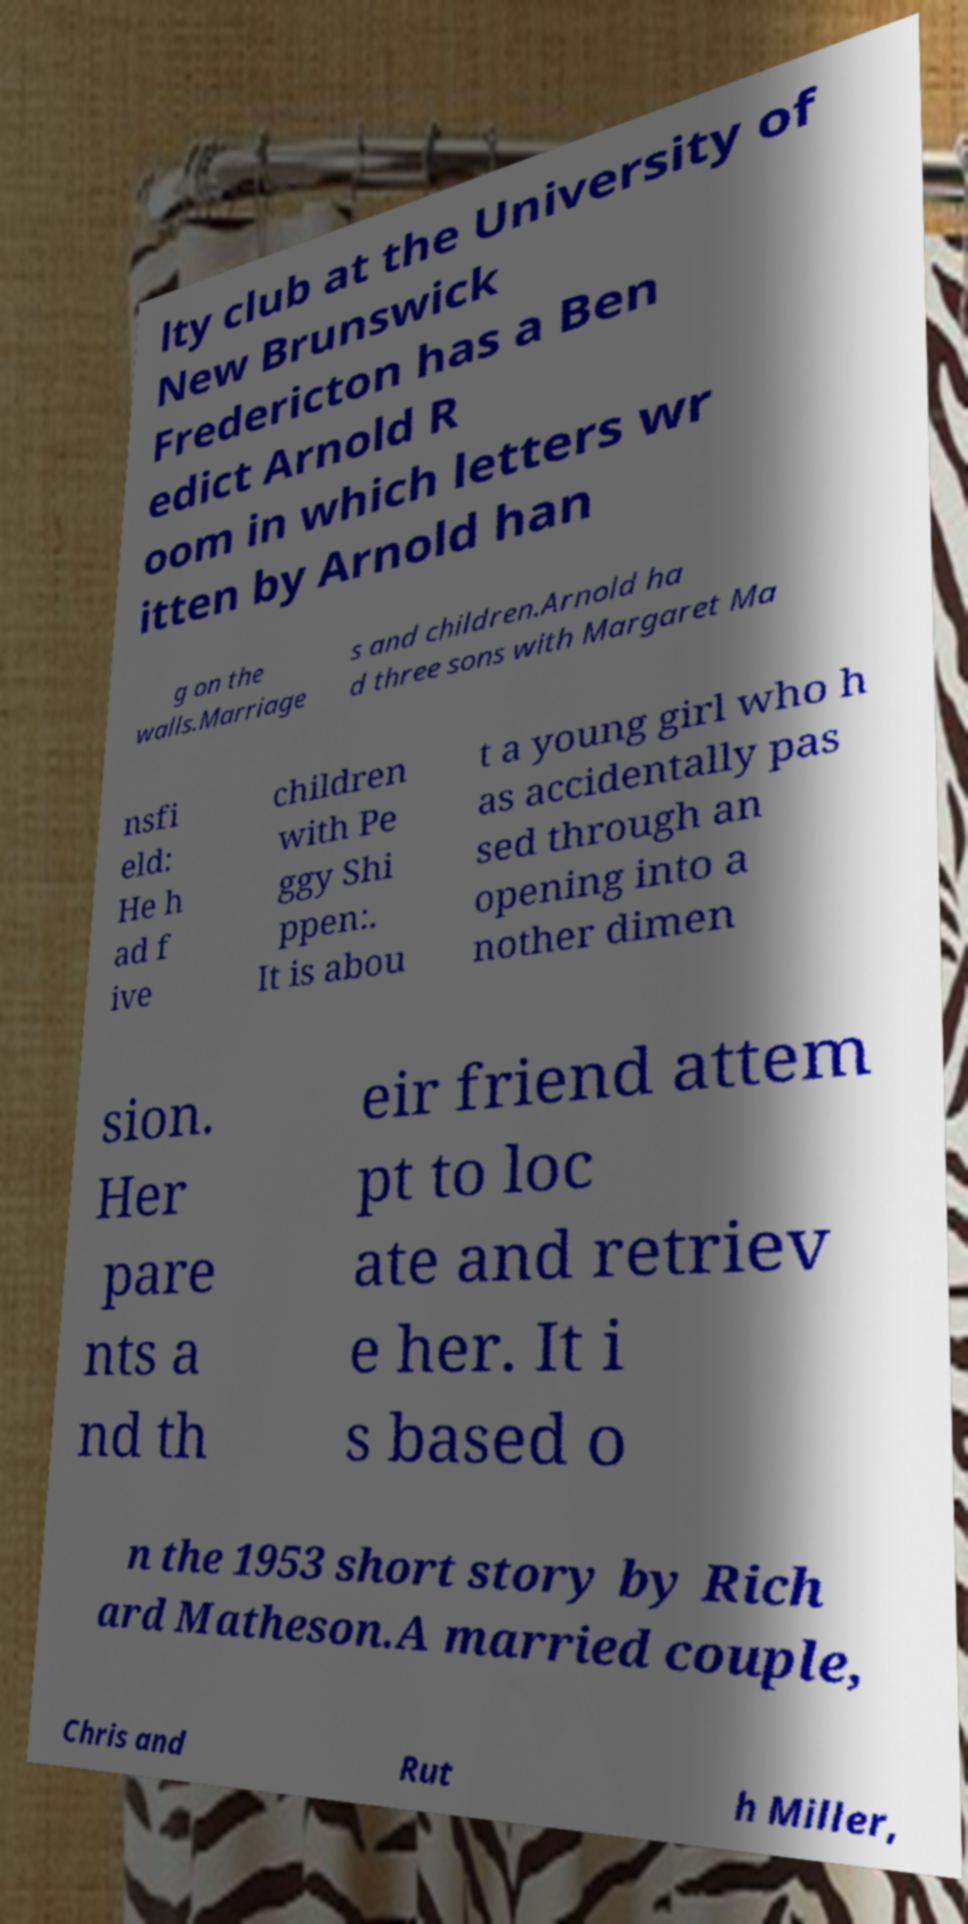Could you assist in decoding the text presented in this image and type it out clearly? lty club at the University of New Brunswick Fredericton has a Ben edict Arnold R oom in which letters wr itten by Arnold han g on the walls.Marriage s and children.Arnold ha d three sons with Margaret Ma nsfi eld: He h ad f ive children with Pe ggy Shi ppen:. It is abou t a young girl who h as accidentally pas sed through an opening into a nother dimen sion. Her pare nts a nd th eir friend attem pt to loc ate and retriev e her. It i s based o n the 1953 short story by Rich ard Matheson.A married couple, Chris and Rut h Miller, 